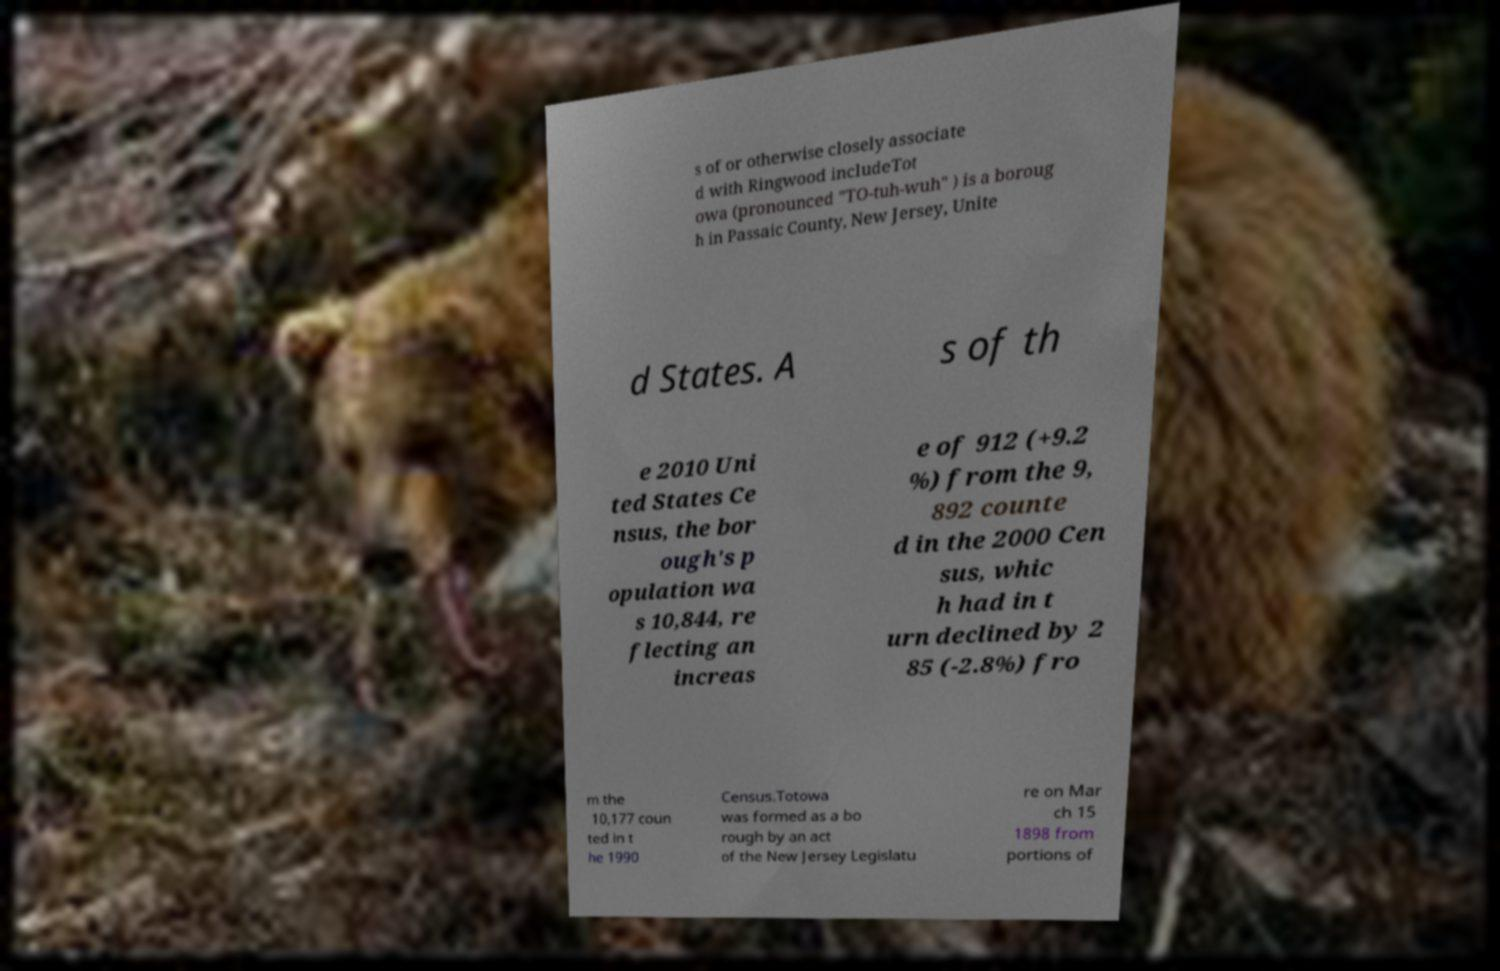Could you assist in decoding the text presented in this image and type it out clearly? s of or otherwise closely associate d with Ringwood includeTot owa (pronounced "TO-tuh-wuh" ) is a boroug h in Passaic County, New Jersey, Unite d States. A s of th e 2010 Uni ted States Ce nsus, the bor ough's p opulation wa s 10,844, re flecting an increas e of 912 (+9.2 %) from the 9, 892 counte d in the 2000 Cen sus, whic h had in t urn declined by 2 85 (-2.8%) fro m the 10,177 coun ted in t he 1990 Census.Totowa was formed as a bo rough by an act of the New Jersey Legislatu re on Mar ch 15 1898 from portions of 